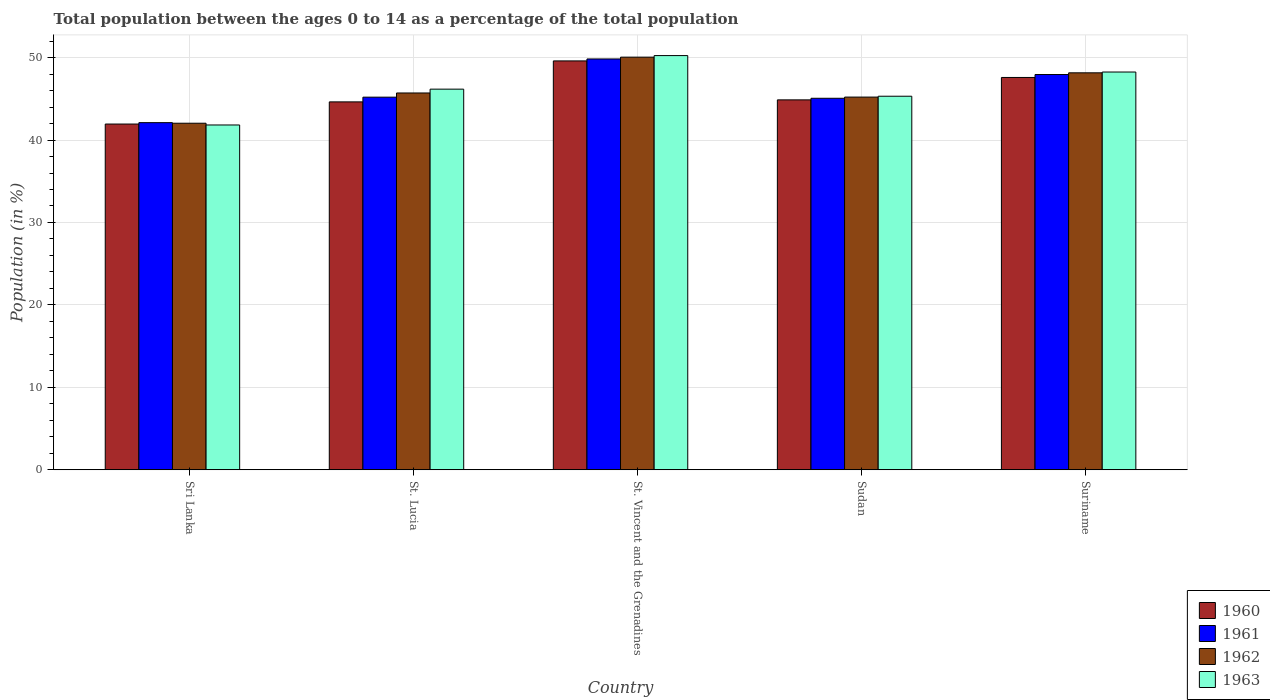How many different coloured bars are there?
Offer a very short reply. 4. How many groups of bars are there?
Provide a short and direct response. 5. Are the number of bars per tick equal to the number of legend labels?
Give a very brief answer. Yes. How many bars are there on the 2nd tick from the left?
Offer a terse response. 4. How many bars are there on the 3rd tick from the right?
Offer a terse response. 4. What is the label of the 2nd group of bars from the left?
Make the answer very short. St. Lucia. In how many cases, is the number of bars for a given country not equal to the number of legend labels?
Provide a short and direct response. 0. What is the percentage of the population ages 0 to 14 in 1962 in St. Lucia?
Provide a succinct answer. 45.71. Across all countries, what is the maximum percentage of the population ages 0 to 14 in 1961?
Keep it short and to the point. 49.83. Across all countries, what is the minimum percentage of the population ages 0 to 14 in 1963?
Keep it short and to the point. 41.82. In which country was the percentage of the population ages 0 to 14 in 1961 maximum?
Make the answer very short. St. Vincent and the Grenadines. In which country was the percentage of the population ages 0 to 14 in 1962 minimum?
Provide a short and direct response. Sri Lanka. What is the total percentage of the population ages 0 to 14 in 1960 in the graph?
Keep it short and to the point. 228.62. What is the difference between the percentage of the population ages 0 to 14 in 1962 in St. Lucia and that in Suriname?
Your answer should be very brief. -2.44. What is the difference between the percentage of the population ages 0 to 14 in 1960 in Sudan and the percentage of the population ages 0 to 14 in 1963 in St. Vincent and the Grenadines?
Ensure brevity in your answer.  -5.37. What is the average percentage of the population ages 0 to 14 in 1960 per country?
Make the answer very short. 45.72. What is the difference between the percentage of the population ages 0 to 14 of/in 1963 and percentage of the population ages 0 to 14 of/in 1960 in Sri Lanka?
Offer a terse response. -0.12. What is the ratio of the percentage of the population ages 0 to 14 in 1962 in St. Vincent and the Grenadines to that in Suriname?
Offer a terse response. 1.04. Is the difference between the percentage of the population ages 0 to 14 in 1963 in Sudan and Suriname greater than the difference between the percentage of the population ages 0 to 14 in 1960 in Sudan and Suriname?
Keep it short and to the point. No. What is the difference between the highest and the second highest percentage of the population ages 0 to 14 in 1962?
Ensure brevity in your answer.  -1.9. What is the difference between the highest and the lowest percentage of the population ages 0 to 14 in 1963?
Provide a short and direct response. 8.42. Is the sum of the percentage of the population ages 0 to 14 in 1962 in Sudan and Suriname greater than the maximum percentage of the population ages 0 to 14 in 1963 across all countries?
Your response must be concise. Yes. What does the 3rd bar from the left in St. Lucia represents?
Give a very brief answer. 1962. How many countries are there in the graph?
Ensure brevity in your answer.  5. Where does the legend appear in the graph?
Keep it short and to the point. Bottom right. How many legend labels are there?
Your answer should be very brief. 4. What is the title of the graph?
Ensure brevity in your answer.  Total population between the ages 0 to 14 as a percentage of the total population. Does "2009" appear as one of the legend labels in the graph?
Ensure brevity in your answer.  No. What is the label or title of the X-axis?
Keep it short and to the point. Country. What is the Population (in %) in 1960 in Sri Lanka?
Offer a terse response. 41.94. What is the Population (in %) in 1961 in Sri Lanka?
Give a very brief answer. 42.11. What is the Population (in %) of 1962 in Sri Lanka?
Offer a very short reply. 42.04. What is the Population (in %) in 1963 in Sri Lanka?
Keep it short and to the point. 41.82. What is the Population (in %) in 1960 in St. Lucia?
Provide a succinct answer. 44.63. What is the Population (in %) in 1961 in St. Lucia?
Your response must be concise. 45.2. What is the Population (in %) of 1962 in St. Lucia?
Your answer should be compact. 45.71. What is the Population (in %) in 1963 in St. Lucia?
Provide a short and direct response. 46.17. What is the Population (in %) in 1960 in St. Vincent and the Grenadines?
Give a very brief answer. 49.59. What is the Population (in %) of 1961 in St. Vincent and the Grenadines?
Offer a very short reply. 49.83. What is the Population (in %) of 1962 in St. Vincent and the Grenadines?
Offer a very short reply. 50.05. What is the Population (in %) in 1963 in St. Vincent and the Grenadines?
Provide a succinct answer. 50.24. What is the Population (in %) in 1960 in Sudan?
Your answer should be compact. 44.87. What is the Population (in %) of 1961 in Sudan?
Offer a very short reply. 45.06. What is the Population (in %) of 1962 in Sudan?
Provide a succinct answer. 45.21. What is the Population (in %) of 1963 in Sudan?
Your answer should be compact. 45.31. What is the Population (in %) in 1960 in Suriname?
Your response must be concise. 47.59. What is the Population (in %) of 1961 in Suriname?
Provide a succinct answer. 47.94. What is the Population (in %) in 1962 in Suriname?
Your answer should be very brief. 48.15. What is the Population (in %) of 1963 in Suriname?
Your answer should be very brief. 48.25. Across all countries, what is the maximum Population (in %) of 1960?
Your response must be concise. 49.59. Across all countries, what is the maximum Population (in %) in 1961?
Your response must be concise. 49.83. Across all countries, what is the maximum Population (in %) in 1962?
Your answer should be very brief. 50.05. Across all countries, what is the maximum Population (in %) in 1963?
Provide a short and direct response. 50.24. Across all countries, what is the minimum Population (in %) of 1960?
Make the answer very short. 41.94. Across all countries, what is the minimum Population (in %) of 1961?
Keep it short and to the point. 42.11. Across all countries, what is the minimum Population (in %) in 1962?
Ensure brevity in your answer.  42.04. Across all countries, what is the minimum Population (in %) of 1963?
Make the answer very short. 41.82. What is the total Population (in %) of 1960 in the graph?
Your answer should be very brief. 228.62. What is the total Population (in %) in 1961 in the graph?
Your response must be concise. 230.15. What is the total Population (in %) of 1962 in the graph?
Give a very brief answer. 231.16. What is the total Population (in %) in 1963 in the graph?
Make the answer very short. 231.8. What is the difference between the Population (in %) of 1960 in Sri Lanka and that in St. Lucia?
Give a very brief answer. -2.69. What is the difference between the Population (in %) in 1961 in Sri Lanka and that in St. Lucia?
Your answer should be very brief. -3.09. What is the difference between the Population (in %) of 1962 in Sri Lanka and that in St. Lucia?
Give a very brief answer. -3.67. What is the difference between the Population (in %) in 1963 in Sri Lanka and that in St. Lucia?
Offer a very short reply. -4.35. What is the difference between the Population (in %) of 1960 in Sri Lanka and that in St. Vincent and the Grenadines?
Provide a succinct answer. -7.66. What is the difference between the Population (in %) of 1961 in Sri Lanka and that in St. Vincent and the Grenadines?
Make the answer very short. -7.72. What is the difference between the Population (in %) in 1962 in Sri Lanka and that in St. Vincent and the Grenadines?
Make the answer very short. -8.02. What is the difference between the Population (in %) in 1963 in Sri Lanka and that in St. Vincent and the Grenadines?
Provide a succinct answer. -8.42. What is the difference between the Population (in %) in 1960 in Sri Lanka and that in Sudan?
Your response must be concise. -2.93. What is the difference between the Population (in %) in 1961 in Sri Lanka and that in Sudan?
Provide a succinct answer. -2.96. What is the difference between the Population (in %) of 1962 in Sri Lanka and that in Sudan?
Provide a short and direct response. -3.17. What is the difference between the Population (in %) in 1963 in Sri Lanka and that in Sudan?
Make the answer very short. -3.49. What is the difference between the Population (in %) of 1960 in Sri Lanka and that in Suriname?
Your answer should be very brief. -5.65. What is the difference between the Population (in %) of 1961 in Sri Lanka and that in Suriname?
Offer a very short reply. -5.84. What is the difference between the Population (in %) in 1962 in Sri Lanka and that in Suriname?
Ensure brevity in your answer.  -6.11. What is the difference between the Population (in %) in 1963 in Sri Lanka and that in Suriname?
Provide a short and direct response. -6.42. What is the difference between the Population (in %) of 1960 in St. Lucia and that in St. Vincent and the Grenadines?
Make the answer very short. -4.97. What is the difference between the Population (in %) of 1961 in St. Lucia and that in St. Vincent and the Grenadines?
Ensure brevity in your answer.  -4.63. What is the difference between the Population (in %) of 1962 in St. Lucia and that in St. Vincent and the Grenadines?
Your response must be concise. -4.35. What is the difference between the Population (in %) in 1963 in St. Lucia and that in St. Vincent and the Grenadines?
Make the answer very short. -4.07. What is the difference between the Population (in %) of 1960 in St. Lucia and that in Sudan?
Offer a very short reply. -0.24. What is the difference between the Population (in %) in 1961 in St. Lucia and that in Sudan?
Give a very brief answer. 0.13. What is the difference between the Population (in %) of 1962 in St. Lucia and that in Sudan?
Your response must be concise. 0.5. What is the difference between the Population (in %) of 1963 in St. Lucia and that in Sudan?
Give a very brief answer. 0.86. What is the difference between the Population (in %) in 1960 in St. Lucia and that in Suriname?
Provide a succinct answer. -2.96. What is the difference between the Population (in %) of 1961 in St. Lucia and that in Suriname?
Provide a succinct answer. -2.75. What is the difference between the Population (in %) in 1962 in St. Lucia and that in Suriname?
Make the answer very short. -2.44. What is the difference between the Population (in %) in 1963 in St. Lucia and that in Suriname?
Ensure brevity in your answer.  -2.08. What is the difference between the Population (in %) in 1960 in St. Vincent and the Grenadines and that in Sudan?
Your answer should be compact. 4.72. What is the difference between the Population (in %) of 1961 in St. Vincent and the Grenadines and that in Sudan?
Give a very brief answer. 4.77. What is the difference between the Population (in %) in 1962 in St. Vincent and the Grenadines and that in Sudan?
Your answer should be very brief. 4.85. What is the difference between the Population (in %) of 1963 in St. Vincent and the Grenadines and that in Sudan?
Provide a short and direct response. 4.93. What is the difference between the Population (in %) of 1960 in St. Vincent and the Grenadines and that in Suriname?
Your answer should be very brief. 2.01. What is the difference between the Population (in %) in 1961 in St. Vincent and the Grenadines and that in Suriname?
Offer a very short reply. 1.89. What is the difference between the Population (in %) in 1962 in St. Vincent and the Grenadines and that in Suriname?
Provide a succinct answer. 1.9. What is the difference between the Population (in %) in 1963 in St. Vincent and the Grenadines and that in Suriname?
Make the answer very short. 1.99. What is the difference between the Population (in %) of 1960 in Sudan and that in Suriname?
Provide a short and direct response. -2.72. What is the difference between the Population (in %) in 1961 in Sudan and that in Suriname?
Provide a succinct answer. -2.88. What is the difference between the Population (in %) in 1962 in Sudan and that in Suriname?
Provide a short and direct response. -2.94. What is the difference between the Population (in %) in 1963 in Sudan and that in Suriname?
Your answer should be compact. -2.94. What is the difference between the Population (in %) of 1960 in Sri Lanka and the Population (in %) of 1961 in St. Lucia?
Offer a very short reply. -3.26. What is the difference between the Population (in %) in 1960 in Sri Lanka and the Population (in %) in 1962 in St. Lucia?
Your response must be concise. -3.77. What is the difference between the Population (in %) of 1960 in Sri Lanka and the Population (in %) of 1963 in St. Lucia?
Offer a very short reply. -4.23. What is the difference between the Population (in %) of 1961 in Sri Lanka and the Population (in %) of 1962 in St. Lucia?
Give a very brief answer. -3.6. What is the difference between the Population (in %) of 1961 in Sri Lanka and the Population (in %) of 1963 in St. Lucia?
Provide a short and direct response. -4.06. What is the difference between the Population (in %) in 1962 in Sri Lanka and the Population (in %) in 1963 in St. Lucia?
Provide a short and direct response. -4.13. What is the difference between the Population (in %) of 1960 in Sri Lanka and the Population (in %) of 1961 in St. Vincent and the Grenadines?
Your response must be concise. -7.89. What is the difference between the Population (in %) of 1960 in Sri Lanka and the Population (in %) of 1962 in St. Vincent and the Grenadines?
Offer a very short reply. -8.11. What is the difference between the Population (in %) of 1960 in Sri Lanka and the Population (in %) of 1963 in St. Vincent and the Grenadines?
Keep it short and to the point. -8.3. What is the difference between the Population (in %) in 1961 in Sri Lanka and the Population (in %) in 1962 in St. Vincent and the Grenadines?
Keep it short and to the point. -7.95. What is the difference between the Population (in %) in 1961 in Sri Lanka and the Population (in %) in 1963 in St. Vincent and the Grenadines?
Keep it short and to the point. -8.13. What is the difference between the Population (in %) of 1962 in Sri Lanka and the Population (in %) of 1963 in St. Vincent and the Grenadines?
Offer a terse response. -8.2. What is the difference between the Population (in %) in 1960 in Sri Lanka and the Population (in %) in 1961 in Sudan?
Your response must be concise. -3.13. What is the difference between the Population (in %) of 1960 in Sri Lanka and the Population (in %) of 1962 in Sudan?
Provide a short and direct response. -3.27. What is the difference between the Population (in %) in 1960 in Sri Lanka and the Population (in %) in 1963 in Sudan?
Provide a short and direct response. -3.37. What is the difference between the Population (in %) of 1961 in Sri Lanka and the Population (in %) of 1962 in Sudan?
Provide a short and direct response. -3.1. What is the difference between the Population (in %) of 1961 in Sri Lanka and the Population (in %) of 1963 in Sudan?
Ensure brevity in your answer.  -3.2. What is the difference between the Population (in %) in 1962 in Sri Lanka and the Population (in %) in 1963 in Sudan?
Give a very brief answer. -3.27. What is the difference between the Population (in %) in 1960 in Sri Lanka and the Population (in %) in 1961 in Suriname?
Make the answer very short. -6. What is the difference between the Population (in %) in 1960 in Sri Lanka and the Population (in %) in 1962 in Suriname?
Give a very brief answer. -6.21. What is the difference between the Population (in %) of 1960 in Sri Lanka and the Population (in %) of 1963 in Suriname?
Provide a short and direct response. -6.31. What is the difference between the Population (in %) of 1961 in Sri Lanka and the Population (in %) of 1962 in Suriname?
Give a very brief answer. -6.04. What is the difference between the Population (in %) in 1961 in Sri Lanka and the Population (in %) in 1963 in Suriname?
Give a very brief answer. -6.14. What is the difference between the Population (in %) of 1962 in Sri Lanka and the Population (in %) of 1963 in Suriname?
Offer a terse response. -6.21. What is the difference between the Population (in %) of 1960 in St. Lucia and the Population (in %) of 1961 in St. Vincent and the Grenadines?
Offer a very short reply. -5.21. What is the difference between the Population (in %) in 1960 in St. Lucia and the Population (in %) in 1962 in St. Vincent and the Grenadines?
Keep it short and to the point. -5.43. What is the difference between the Population (in %) of 1960 in St. Lucia and the Population (in %) of 1963 in St. Vincent and the Grenadines?
Offer a very short reply. -5.62. What is the difference between the Population (in %) in 1961 in St. Lucia and the Population (in %) in 1962 in St. Vincent and the Grenadines?
Provide a succinct answer. -4.85. What is the difference between the Population (in %) of 1961 in St. Lucia and the Population (in %) of 1963 in St. Vincent and the Grenadines?
Provide a short and direct response. -5.04. What is the difference between the Population (in %) of 1962 in St. Lucia and the Population (in %) of 1963 in St. Vincent and the Grenadines?
Your answer should be compact. -4.53. What is the difference between the Population (in %) of 1960 in St. Lucia and the Population (in %) of 1961 in Sudan?
Offer a very short reply. -0.44. What is the difference between the Population (in %) of 1960 in St. Lucia and the Population (in %) of 1962 in Sudan?
Offer a terse response. -0.58. What is the difference between the Population (in %) in 1960 in St. Lucia and the Population (in %) in 1963 in Sudan?
Provide a short and direct response. -0.69. What is the difference between the Population (in %) in 1961 in St. Lucia and the Population (in %) in 1962 in Sudan?
Provide a short and direct response. -0.01. What is the difference between the Population (in %) in 1961 in St. Lucia and the Population (in %) in 1963 in Sudan?
Your answer should be very brief. -0.11. What is the difference between the Population (in %) of 1962 in St. Lucia and the Population (in %) of 1963 in Sudan?
Provide a succinct answer. 0.4. What is the difference between the Population (in %) of 1960 in St. Lucia and the Population (in %) of 1961 in Suriname?
Offer a terse response. -3.32. What is the difference between the Population (in %) of 1960 in St. Lucia and the Population (in %) of 1962 in Suriname?
Give a very brief answer. -3.53. What is the difference between the Population (in %) in 1960 in St. Lucia and the Population (in %) in 1963 in Suriname?
Offer a very short reply. -3.62. What is the difference between the Population (in %) of 1961 in St. Lucia and the Population (in %) of 1962 in Suriname?
Keep it short and to the point. -2.95. What is the difference between the Population (in %) of 1961 in St. Lucia and the Population (in %) of 1963 in Suriname?
Provide a short and direct response. -3.05. What is the difference between the Population (in %) in 1962 in St. Lucia and the Population (in %) in 1963 in Suriname?
Give a very brief answer. -2.54. What is the difference between the Population (in %) in 1960 in St. Vincent and the Grenadines and the Population (in %) in 1961 in Sudan?
Provide a succinct answer. 4.53. What is the difference between the Population (in %) in 1960 in St. Vincent and the Grenadines and the Population (in %) in 1962 in Sudan?
Offer a terse response. 4.39. What is the difference between the Population (in %) in 1960 in St. Vincent and the Grenadines and the Population (in %) in 1963 in Sudan?
Provide a succinct answer. 4.28. What is the difference between the Population (in %) in 1961 in St. Vincent and the Grenadines and the Population (in %) in 1962 in Sudan?
Make the answer very short. 4.62. What is the difference between the Population (in %) in 1961 in St. Vincent and the Grenadines and the Population (in %) in 1963 in Sudan?
Your answer should be compact. 4.52. What is the difference between the Population (in %) in 1962 in St. Vincent and the Grenadines and the Population (in %) in 1963 in Sudan?
Make the answer very short. 4.74. What is the difference between the Population (in %) of 1960 in St. Vincent and the Grenadines and the Population (in %) of 1961 in Suriname?
Make the answer very short. 1.65. What is the difference between the Population (in %) of 1960 in St. Vincent and the Grenadines and the Population (in %) of 1962 in Suriname?
Your answer should be compact. 1.44. What is the difference between the Population (in %) of 1960 in St. Vincent and the Grenadines and the Population (in %) of 1963 in Suriname?
Your answer should be very brief. 1.35. What is the difference between the Population (in %) of 1961 in St. Vincent and the Grenadines and the Population (in %) of 1962 in Suriname?
Your answer should be compact. 1.68. What is the difference between the Population (in %) of 1961 in St. Vincent and the Grenadines and the Population (in %) of 1963 in Suriname?
Offer a very short reply. 1.58. What is the difference between the Population (in %) of 1962 in St. Vincent and the Grenadines and the Population (in %) of 1963 in Suriname?
Offer a terse response. 1.8. What is the difference between the Population (in %) of 1960 in Sudan and the Population (in %) of 1961 in Suriname?
Your response must be concise. -3.07. What is the difference between the Population (in %) in 1960 in Sudan and the Population (in %) in 1962 in Suriname?
Provide a short and direct response. -3.28. What is the difference between the Population (in %) in 1960 in Sudan and the Population (in %) in 1963 in Suriname?
Offer a terse response. -3.38. What is the difference between the Population (in %) in 1961 in Sudan and the Population (in %) in 1962 in Suriname?
Your answer should be compact. -3.09. What is the difference between the Population (in %) in 1961 in Sudan and the Population (in %) in 1963 in Suriname?
Keep it short and to the point. -3.18. What is the difference between the Population (in %) in 1962 in Sudan and the Population (in %) in 1963 in Suriname?
Offer a terse response. -3.04. What is the average Population (in %) in 1960 per country?
Offer a very short reply. 45.72. What is the average Population (in %) in 1961 per country?
Your response must be concise. 46.03. What is the average Population (in %) of 1962 per country?
Your answer should be compact. 46.23. What is the average Population (in %) in 1963 per country?
Make the answer very short. 46.36. What is the difference between the Population (in %) in 1960 and Population (in %) in 1961 in Sri Lanka?
Give a very brief answer. -0.17. What is the difference between the Population (in %) of 1960 and Population (in %) of 1962 in Sri Lanka?
Ensure brevity in your answer.  -0.1. What is the difference between the Population (in %) in 1960 and Population (in %) in 1963 in Sri Lanka?
Offer a very short reply. 0.12. What is the difference between the Population (in %) of 1961 and Population (in %) of 1962 in Sri Lanka?
Provide a succinct answer. 0.07. What is the difference between the Population (in %) of 1961 and Population (in %) of 1963 in Sri Lanka?
Your answer should be very brief. 0.28. What is the difference between the Population (in %) of 1962 and Population (in %) of 1963 in Sri Lanka?
Make the answer very short. 0.21. What is the difference between the Population (in %) of 1960 and Population (in %) of 1961 in St. Lucia?
Offer a terse response. -0.57. What is the difference between the Population (in %) of 1960 and Population (in %) of 1962 in St. Lucia?
Offer a very short reply. -1.08. What is the difference between the Population (in %) in 1960 and Population (in %) in 1963 in St. Lucia?
Provide a short and direct response. -1.55. What is the difference between the Population (in %) in 1961 and Population (in %) in 1962 in St. Lucia?
Ensure brevity in your answer.  -0.51. What is the difference between the Population (in %) of 1961 and Population (in %) of 1963 in St. Lucia?
Give a very brief answer. -0.97. What is the difference between the Population (in %) of 1962 and Population (in %) of 1963 in St. Lucia?
Offer a very short reply. -0.46. What is the difference between the Population (in %) in 1960 and Population (in %) in 1961 in St. Vincent and the Grenadines?
Your answer should be compact. -0.24. What is the difference between the Population (in %) in 1960 and Population (in %) in 1962 in St. Vincent and the Grenadines?
Make the answer very short. -0.46. What is the difference between the Population (in %) of 1960 and Population (in %) of 1963 in St. Vincent and the Grenadines?
Your response must be concise. -0.65. What is the difference between the Population (in %) of 1961 and Population (in %) of 1962 in St. Vincent and the Grenadines?
Offer a very short reply. -0.22. What is the difference between the Population (in %) of 1961 and Population (in %) of 1963 in St. Vincent and the Grenadines?
Your response must be concise. -0.41. What is the difference between the Population (in %) in 1962 and Population (in %) in 1963 in St. Vincent and the Grenadines?
Provide a succinct answer. -0.19. What is the difference between the Population (in %) in 1960 and Population (in %) in 1961 in Sudan?
Ensure brevity in your answer.  -0.19. What is the difference between the Population (in %) in 1960 and Population (in %) in 1962 in Sudan?
Ensure brevity in your answer.  -0.34. What is the difference between the Population (in %) of 1960 and Population (in %) of 1963 in Sudan?
Ensure brevity in your answer.  -0.44. What is the difference between the Population (in %) in 1961 and Population (in %) in 1962 in Sudan?
Your answer should be very brief. -0.14. What is the difference between the Population (in %) of 1961 and Population (in %) of 1963 in Sudan?
Ensure brevity in your answer.  -0.25. What is the difference between the Population (in %) of 1962 and Population (in %) of 1963 in Sudan?
Your answer should be very brief. -0.1. What is the difference between the Population (in %) in 1960 and Population (in %) in 1961 in Suriname?
Provide a succinct answer. -0.35. What is the difference between the Population (in %) in 1960 and Population (in %) in 1962 in Suriname?
Offer a very short reply. -0.56. What is the difference between the Population (in %) of 1960 and Population (in %) of 1963 in Suriname?
Keep it short and to the point. -0.66. What is the difference between the Population (in %) of 1961 and Population (in %) of 1962 in Suriname?
Offer a very short reply. -0.21. What is the difference between the Population (in %) of 1961 and Population (in %) of 1963 in Suriname?
Your response must be concise. -0.3. What is the difference between the Population (in %) in 1962 and Population (in %) in 1963 in Suriname?
Offer a very short reply. -0.1. What is the ratio of the Population (in %) in 1960 in Sri Lanka to that in St. Lucia?
Your answer should be compact. 0.94. What is the ratio of the Population (in %) in 1961 in Sri Lanka to that in St. Lucia?
Make the answer very short. 0.93. What is the ratio of the Population (in %) of 1962 in Sri Lanka to that in St. Lucia?
Offer a terse response. 0.92. What is the ratio of the Population (in %) of 1963 in Sri Lanka to that in St. Lucia?
Offer a terse response. 0.91. What is the ratio of the Population (in %) in 1960 in Sri Lanka to that in St. Vincent and the Grenadines?
Offer a terse response. 0.85. What is the ratio of the Population (in %) of 1961 in Sri Lanka to that in St. Vincent and the Grenadines?
Give a very brief answer. 0.84. What is the ratio of the Population (in %) of 1962 in Sri Lanka to that in St. Vincent and the Grenadines?
Offer a terse response. 0.84. What is the ratio of the Population (in %) in 1963 in Sri Lanka to that in St. Vincent and the Grenadines?
Offer a very short reply. 0.83. What is the ratio of the Population (in %) in 1960 in Sri Lanka to that in Sudan?
Offer a terse response. 0.93. What is the ratio of the Population (in %) in 1961 in Sri Lanka to that in Sudan?
Offer a terse response. 0.93. What is the ratio of the Population (in %) in 1962 in Sri Lanka to that in Sudan?
Provide a short and direct response. 0.93. What is the ratio of the Population (in %) of 1963 in Sri Lanka to that in Sudan?
Offer a very short reply. 0.92. What is the ratio of the Population (in %) in 1960 in Sri Lanka to that in Suriname?
Provide a succinct answer. 0.88. What is the ratio of the Population (in %) in 1961 in Sri Lanka to that in Suriname?
Your response must be concise. 0.88. What is the ratio of the Population (in %) in 1962 in Sri Lanka to that in Suriname?
Offer a very short reply. 0.87. What is the ratio of the Population (in %) of 1963 in Sri Lanka to that in Suriname?
Provide a short and direct response. 0.87. What is the ratio of the Population (in %) of 1960 in St. Lucia to that in St. Vincent and the Grenadines?
Offer a terse response. 0.9. What is the ratio of the Population (in %) in 1961 in St. Lucia to that in St. Vincent and the Grenadines?
Your answer should be very brief. 0.91. What is the ratio of the Population (in %) of 1962 in St. Lucia to that in St. Vincent and the Grenadines?
Provide a succinct answer. 0.91. What is the ratio of the Population (in %) in 1963 in St. Lucia to that in St. Vincent and the Grenadines?
Your response must be concise. 0.92. What is the ratio of the Population (in %) of 1961 in St. Lucia to that in Sudan?
Your response must be concise. 1. What is the ratio of the Population (in %) of 1962 in St. Lucia to that in Sudan?
Give a very brief answer. 1.01. What is the ratio of the Population (in %) of 1963 in St. Lucia to that in Sudan?
Your response must be concise. 1.02. What is the ratio of the Population (in %) of 1960 in St. Lucia to that in Suriname?
Offer a very short reply. 0.94. What is the ratio of the Population (in %) in 1961 in St. Lucia to that in Suriname?
Make the answer very short. 0.94. What is the ratio of the Population (in %) of 1962 in St. Lucia to that in Suriname?
Provide a succinct answer. 0.95. What is the ratio of the Population (in %) in 1960 in St. Vincent and the Grenadines to that in Sudan?
Your answer should be compact. 1.11. What is the ratio of the Population (in %) of 1961 in St. Vincent and the Grenadines to that in Sudan?
Offer a terse response. 1.11. What is the ratio of the Population (in %) in 1962 in St. Vincent and the Grenadines to that in Sudan?
Your answer should be compact. 1.11. What is the ratio of the Population (in %) of 1963 in St. Vincent and the Grenadines to that in Sudan?
Your response must be concise. 1.11. What is the ratio of the Population (in %) in 1960 in St. Vincent and the Grenadines to that in Suriname?
Offer a terse response. 1.04. What is the ratio of the Population (in %) of 1961 in St. Vincent and the Grenadines to that in Suriname?
Offer a terse response. 1.04. What is the ratio of the Population (in %) in 1962 in St. Vincent and the Grenadines to that in Suriname?
Offer a terse response. 1.04. What is the ratio of the Population (in %) in 1963 in St. Vincent and the Grenadines to that in Suriname?
Your response must be concise. 1.04. What is the ratio of the Population (in %) of 1960 in Sudan to that in Suriname?
Give a very brief answer. 0.94. What is the ratio of the Population (in %) in 1961 in Sudan to that in Suriname?
Keep it short and to the point. 0.94. What is the ratio of the Population (in %) in 1962 in Sudan to that in Suriname?
Your answer should be compact. 0.94. What is the ratio of the Population (in %) of 1963 in Sudan to that in Suriname?
Make the answer very short. 0.94. What is the difference between the highest and the second highest Population (in %) of 1960?
Provide a short and direct response. 2.01. What is the difference between the highest and the second highest Population (in %) of 1961?
Your answer should be very brief. 1.89. What is the difference between the highest and the second highest Population (in %) in 1962?
Your answer should be very brief. 1.9. What is the difference between the highest and the second highest Population (in %) in 1963?
Provide a succinct answer. 1.99. What is the difference between the highest and the lowest Population (in %) in 1960?
Your answer should be very brief. 7.66. What is the difference between the highest and the lowest Population (in %) of 1961?
Keep it short and to the point. 7.72. What is the difference between the highest and the lowest Population (in %) of 1962?
Provide a short and direct response. 8.02. What is the difference between the highest and the lowest Population (in %) in 1963?
Your answer should be very brief. 8.42. 